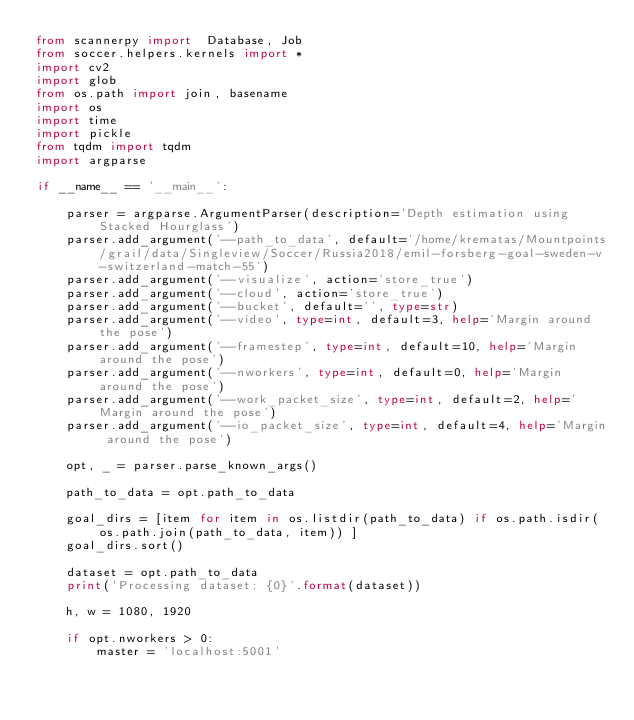<code> <loc_0><loc_0><loc_500><loc_500><_Python_>from scannerpy import  Database, Job
from soccer.helpers.kernels import *
import cv2
import glob
from os.path import join, basename
import os
import time
import pickle
from tqdm import tqdm
import argparse

if __name__ == '__main__':

    parser = argparse.ArgumentParser(description='Depth estimation using Stacked Hourglass')
    parser.add_argument('--path_to_data', default='/home/krematas/Mountpoints/grail/data/Singleview/Soccer/Russia2018/emil-forsberg-goal-sweden-v-switzerland-match-55')
    parser.add_argument('--visualize', action='store_true')
    parser.add_argument('--cloud', action='store_true')
    parser.add_argument('--bucket', default='', type=str)
    parser.add_argument('--video', type=int, default=3, help='Margin around the pose')
    parser.add_argument('--framestep', type=int, default=10, help='Margin around the pose')
    parser.add_argument('--nworkers', type=int, default=0, help='Margin around the pose')
    parser.add_argument('--work_packet_size', type=int, default=2, help='Margin around the pose')
    parser.add_argument('--io_packet_size', type=int, default=4, help='Margin around the pose')

    opt, _ = parser.parse_known_args()

    path_to_data = opt.path_to_data

    goal_dirs = [item for item in os.listdir(path_to_data) if os.path.isdir(os.path.join(path_to_data, item)) ]
    goal_dirs.sort()

    dataset = opt.path_to_data
    print('Processing dataset: {0}'.format(dataset))

    h, w = 1080, 1920

    if opt.nworkers > 0:
        master = 'localhost:5001'</code> 